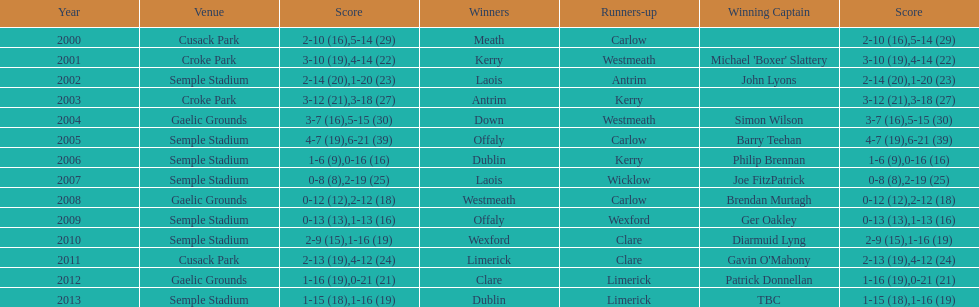Who scored the least? Wicklow. 